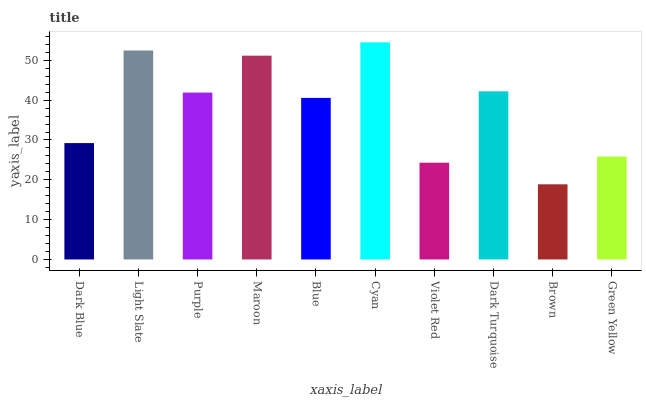Is Light Slate the minimum?
Answer yes or no. No. Is Light Slate the maximum?
Answer yes or no. No. Is Light Slate greater than Dark Blue?
Answer yes or no. Yes. Is Dark Blue less than Light Slate?
Answer yes or no. Yes. Is Dark Blue greater than Light Slate?
Answer yes or no. No. Is Light Slate less than Dark Blue?
Answer yes or no. No. Is Purple the high median?
Answer yes or no. Yes. Is Blue the low median?
Answer yes or no. Yes. Is Brown the high median?
Answer yes or no. No. Is Light Slate the low median?
Answer yes or no. No. 